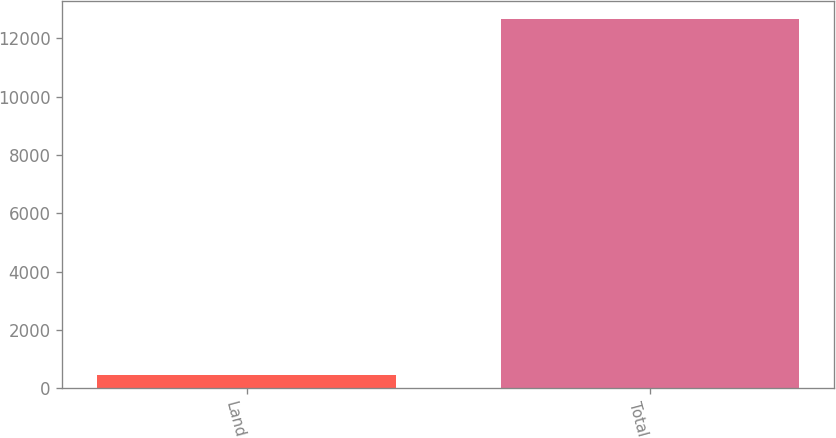Convert chart to OTSL. <chart><loc_0><loc_0><loc_500><loc_500><bar_chart><fcel>Land<fcel>Total<nl><fcel>438<fcel>12648<nl></chart> 